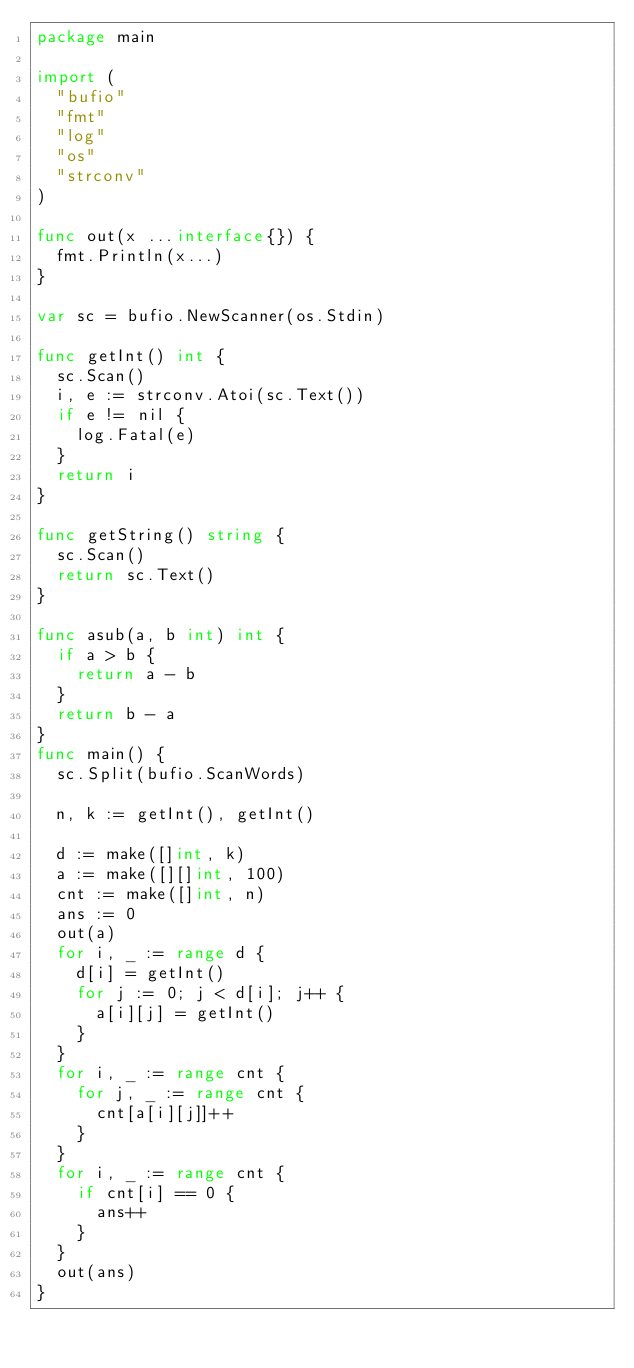Convert code to text. <code><loc_0><loc_0><loc_500><loc_500><_Go_>package main

import (
	"bufio"
	"fmt"
	"log"
	"os"
	"strconv"
)

func out(x ...interface{}) {
	fmt.Println(x...)
}

var sc = bufio.NewScanner(os.Stdin)

func getInt() int {
	sc.Scan()
	i, e := strconv.Atoi(sc.Text())
	if e != nil {
		log.Fatal(e)
	}
	return i
}

func getString() string {
	sc.Scan()
	return sc.Text()
}

func asub(a, b int) int {
	if a > b {
		return a - b
	}
	return b - a
}
func main() {
	sc.Split(bufio.ScanWords)

	n, k := getInt(), getInt()

	d := make([]int, k)
	a := make([][]int, 100)
	cnt := make([]int, n)
	ans := 0
	out(a)
	for i, _ := range d {
		d[i] = getInt()
		for j := 0; j < d[i]; j++ {
			a[i][j] = getInt()
		}
	}
	for i, _ := range cnt {
		for j, _ := range cnt {
			cnt[a[i][j]]++
		}
	}
	for i, _ := range cnt {
		if cnt[i] == 0 {
			ans++
		}
	}
	out(ans)
}
</code> 